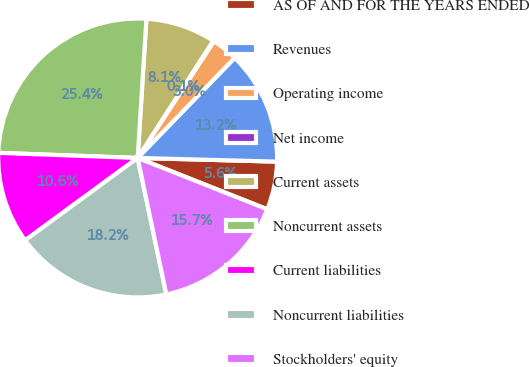<chart> <loc_0><loc_0><loc_500><loc_500><pie_chart><fcel>AS OF AND FOR THE YEARS ENDED<fcel>Revenues<fcel>Operating income<fcel>Net income<fcel>Current assets<fcel>Noncurrent assets<fcel>Current liabilities<fcel>Noncurrent liabilities<fcel>Stockholders' equity<nl><fcel>5.58%<fcel>13.17%<fcel>3.04%<fcel>0.1%<fcel>8.11%<fcel>25.42%<fcel>10.64%<fcel>18.24%<fcel>15.7%<nl></chart> 